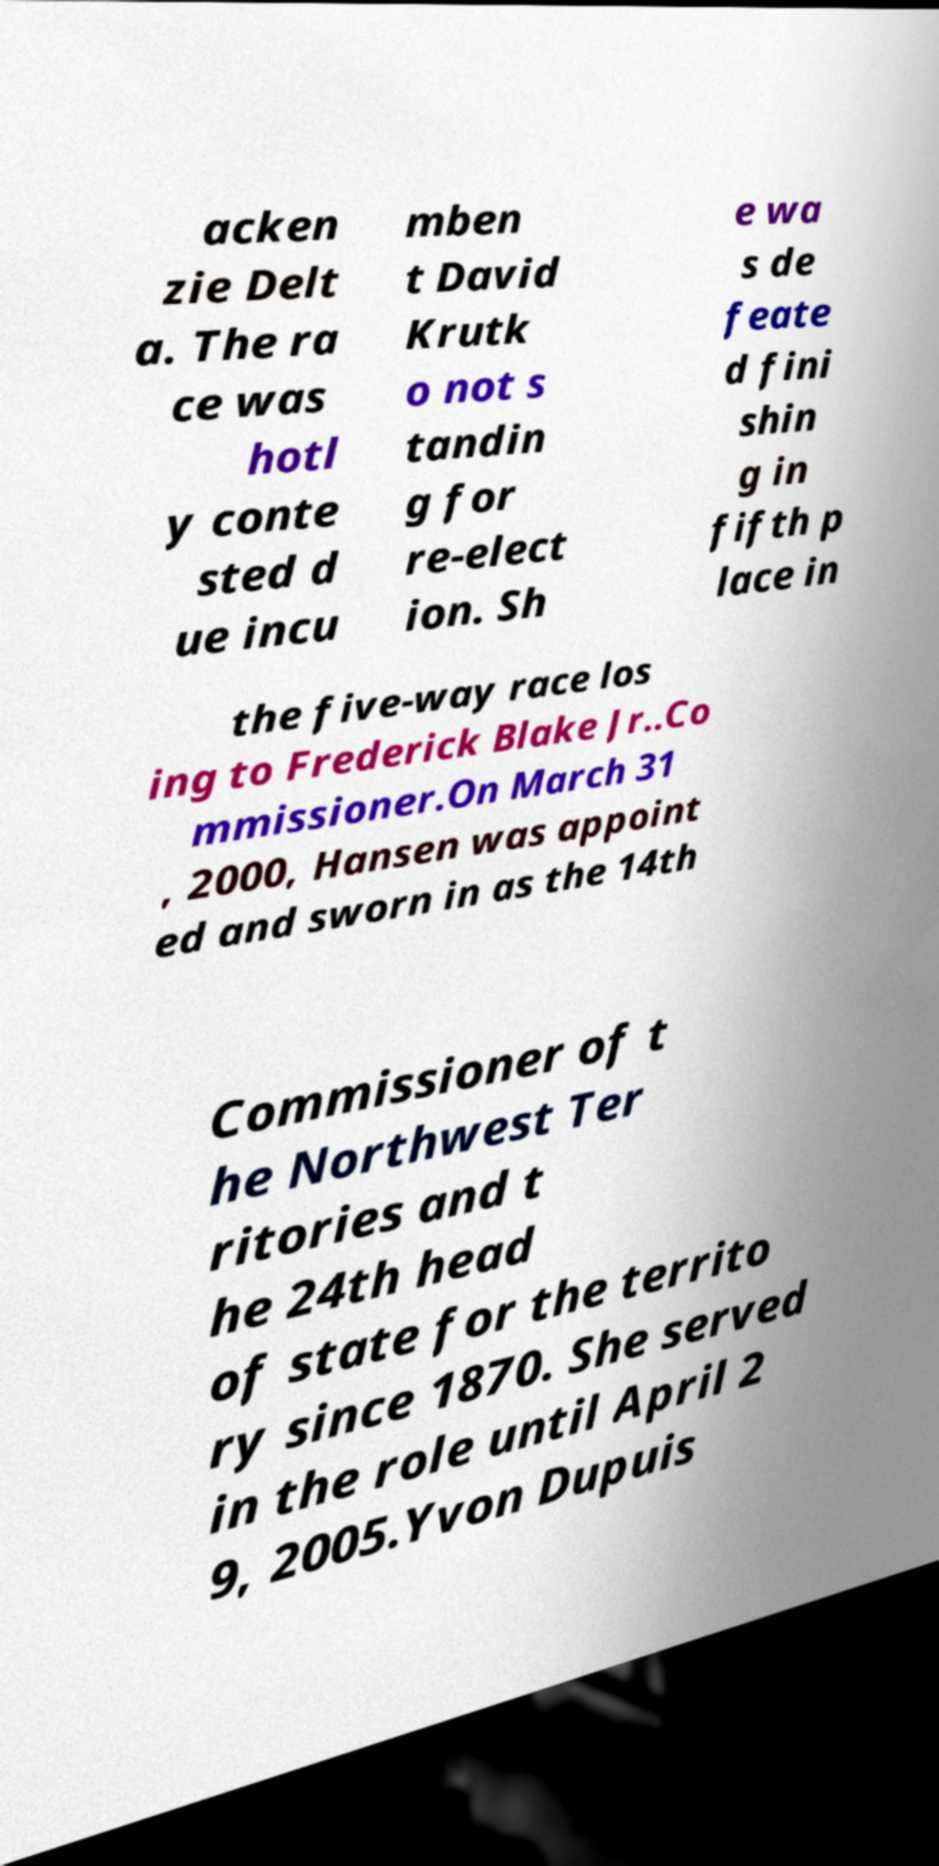For documentation purposes, I need the text within this image transcribed. Could you provide that? acken zie Delt a. The ra ce was hotl y conte sted d ue incu mben t David Krutk o not s tandin g for re-elect ion. Sh e wa s de feate d fini shin g in fifth p lace in the five-way race los ing to Frederick Blake Jr..Co mmissioner.On March 31 , 2000, Hansen was appoint ed and sworn in as the 14th Commissioner of t he Northwest Ter ritories and t he 24th head of state for the territo ry since 1870. She served in the role until April 2 9, 2005.Yvon Dupuis 